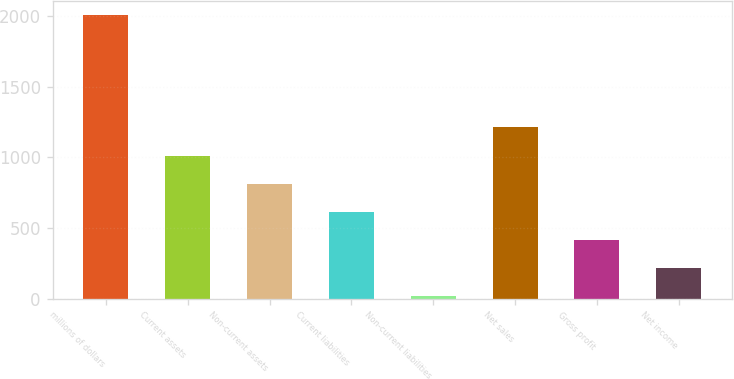Convert chart. <chart><loc_0><loc_0><loc_500><loc_500><bar_chart><fcel>millions of dollars<fcel>Current assets<fcel>Non-current assets<fcel>Current liabilities<fcel>Non-current liabilities<fcel>Net sales<fcel>Gross profit<fcel>Net income<nl><fcel>2006<fcel>1012.85<fcel>814.22<fcel>615.59<fcel>19.7<fcel>1211.48<fcel>416.96<fcel>218.33<nl></chart> 